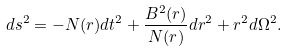Convert formula to latex. <formula><loc_0><loc_0><loc_500><loc_500>d s ^ { 2 } = - N ( r ) d t ^ { 2 } + \frac { B ^ { 2 } ( r ) } { N ( r ) } d r ^ { 2 } + r ^ { 2 } d \Omega ^ { 2 } .</formula> 